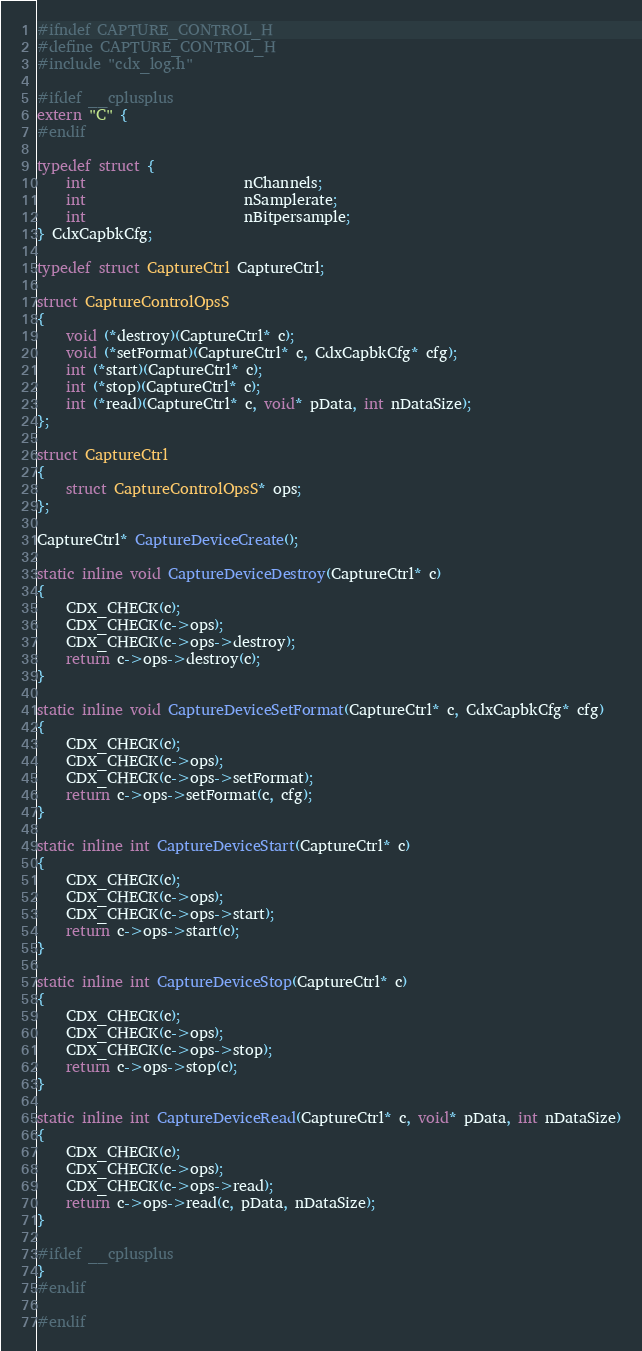<code> <loc_0><loc_0><loc_500><loc_500><_C_>#ifndef CAPTURE_CONTROL_H
#define CAPTURE_CONTROL_H
#include "cdx_log.h"

#ifdef __cplusplus
extern "C" {
#endif

typedef struct {
    int                      nChannels;
    int                      nSamplerate;
    int                      nBitpersample;
} CdxCapbkCfg;

typedef struct CaptureCtrl CaptureCtrl;

struct CaptureControlOpsS
{
    void (*destroy)(CaptureCtrl* c);
    void (*setFormat)(CaptureCtrl* c, CdxCapbkCfg* cfg);
    int (*start)(CaptureCtrl* c);
    int (*stop)(CaptureCtrl* c);
    int (*read)(CaptureCtrl* c, void* pData, int nDataSize);
};

struct CaptureCtrl
{
    struct CaptureControlOpsS* ops;
};

CaptureCtrl* CaptureDeviceCreate();

static inline void CaptureDeviceDestroy(CaptureCtrl* c)
{
    CDX_CHECK(c);
    CDX_CHECK(c->ops);
    CDX_CHECK(c->ops->destroy);
    return c->ops->destroy(c);
}

static inline void CaptureDeviceSetFormat(CaptureCtrl* c, CdxCapbkCfg* cfg)
{
    CDX_CHECK(c);
    CDX_CHECK(c->ops);
    CDX_CHECK(c->ops->setFormat);
    return c->ops->setFormat(c, cfg);
}

static inline int CaptureDeviceStart(CaptureCtrl* c)
{
    CDX_CHECK(c);
    CDX_CHECK(c->ops);
    CDX_CHECK(c->ops->start);
    return c->ops->start(c);
}

static inline int CaptureDeviceStop(CaptureCtrl* c)
{
    CDX_CHECK(c);
    CDX_CHECK(c->ops);
    CDX_CHECK(c->ops->stop);
    return c->ops->stop(c);
}

static inline int CaptureDeviceRead(CaptureCtrl* c, void* pData, int nDataSize)
{
    CDX_CHECK(c);
    CDX_CHECK(c->ops);
    CDX_CHECK(c->ops->read);
    return c->ops->read(c, pData, nDataSize);
}

#ifdef __cplusplus
}
#endif

#endif
</code> 